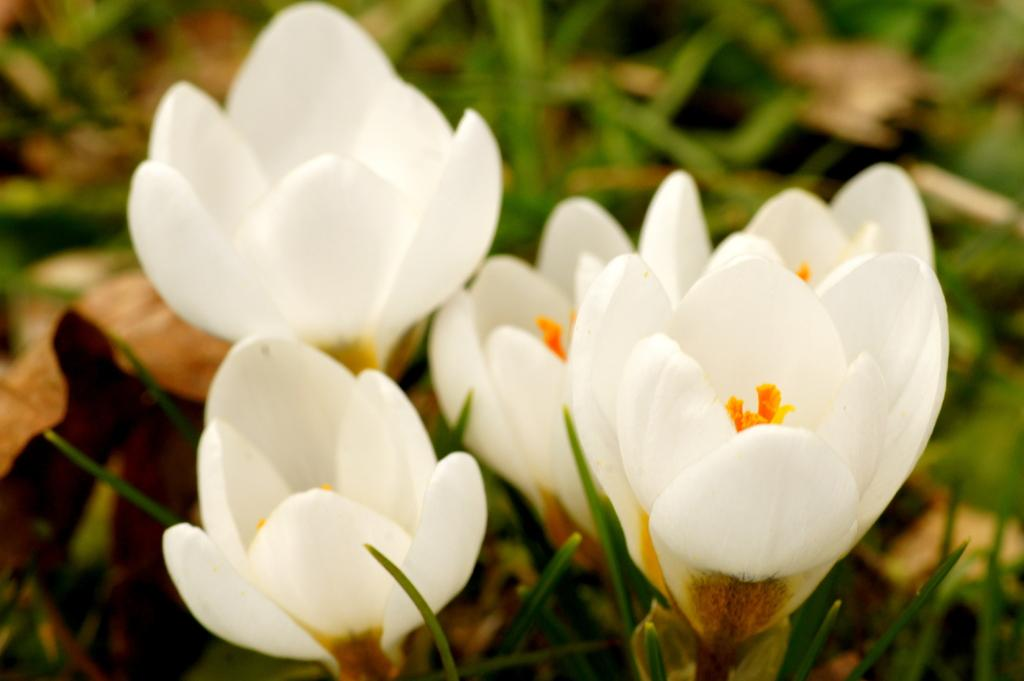What colors of flowers can be seen in the image? There are white, yellow, and orange flowers in the image. What are the flowers attached to? The flowers are on plants. How would you describe the background of the image? The background of the image is blurred. Can you see a train in the image? No, there is no train present in the image. 